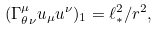<formula> <loc_0><loc_0><loc_500><loc_500>( \Gamma ^ { \mu } _ { \theta \nu } u _ { \mu } u ^ { \nu } ) _ { 1 } = \ell _ { * } ^ { 2 } / r ^ { 2 } ,</formula> 